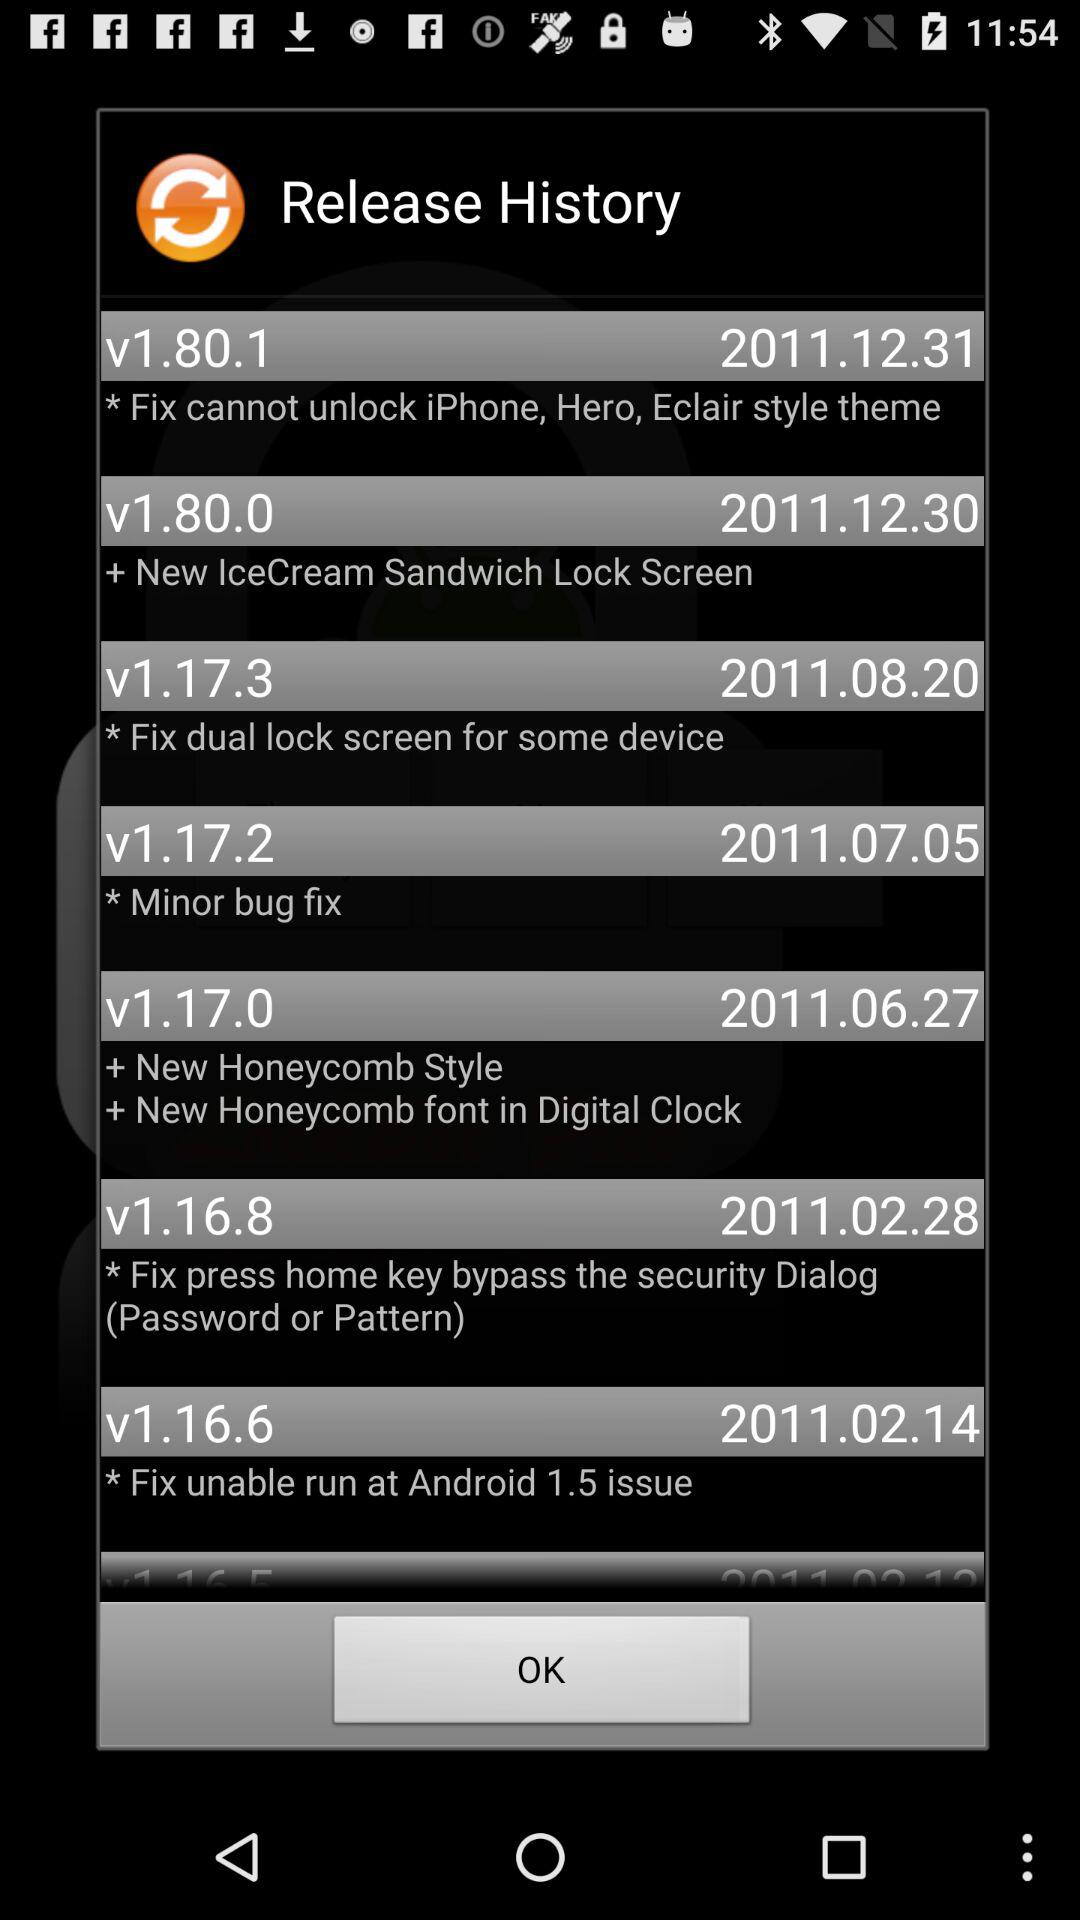What is the release date of the version number v1.17.3? The release date is August 20, 2011. 